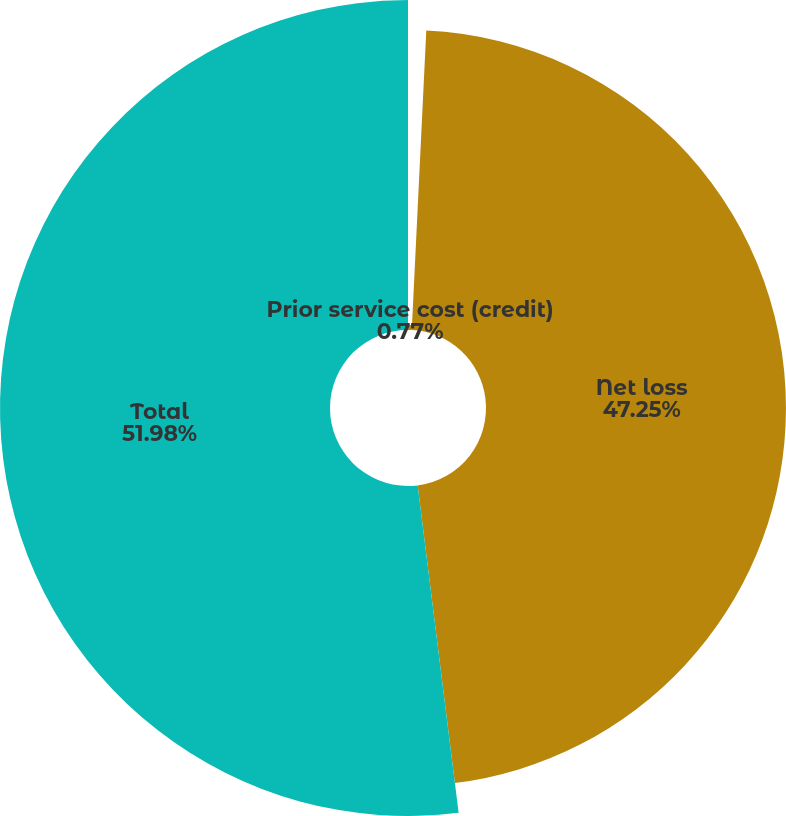Convert chart. <chart><loc_0><loc_0><loc_500><loc_500><pie_chart><fcel>Prior service cost (credit)<fcel>Net loss<fcel>Total<nl><fcel>0.77%<fcel>47.25%<fcel>51.98%<nl></chart> 